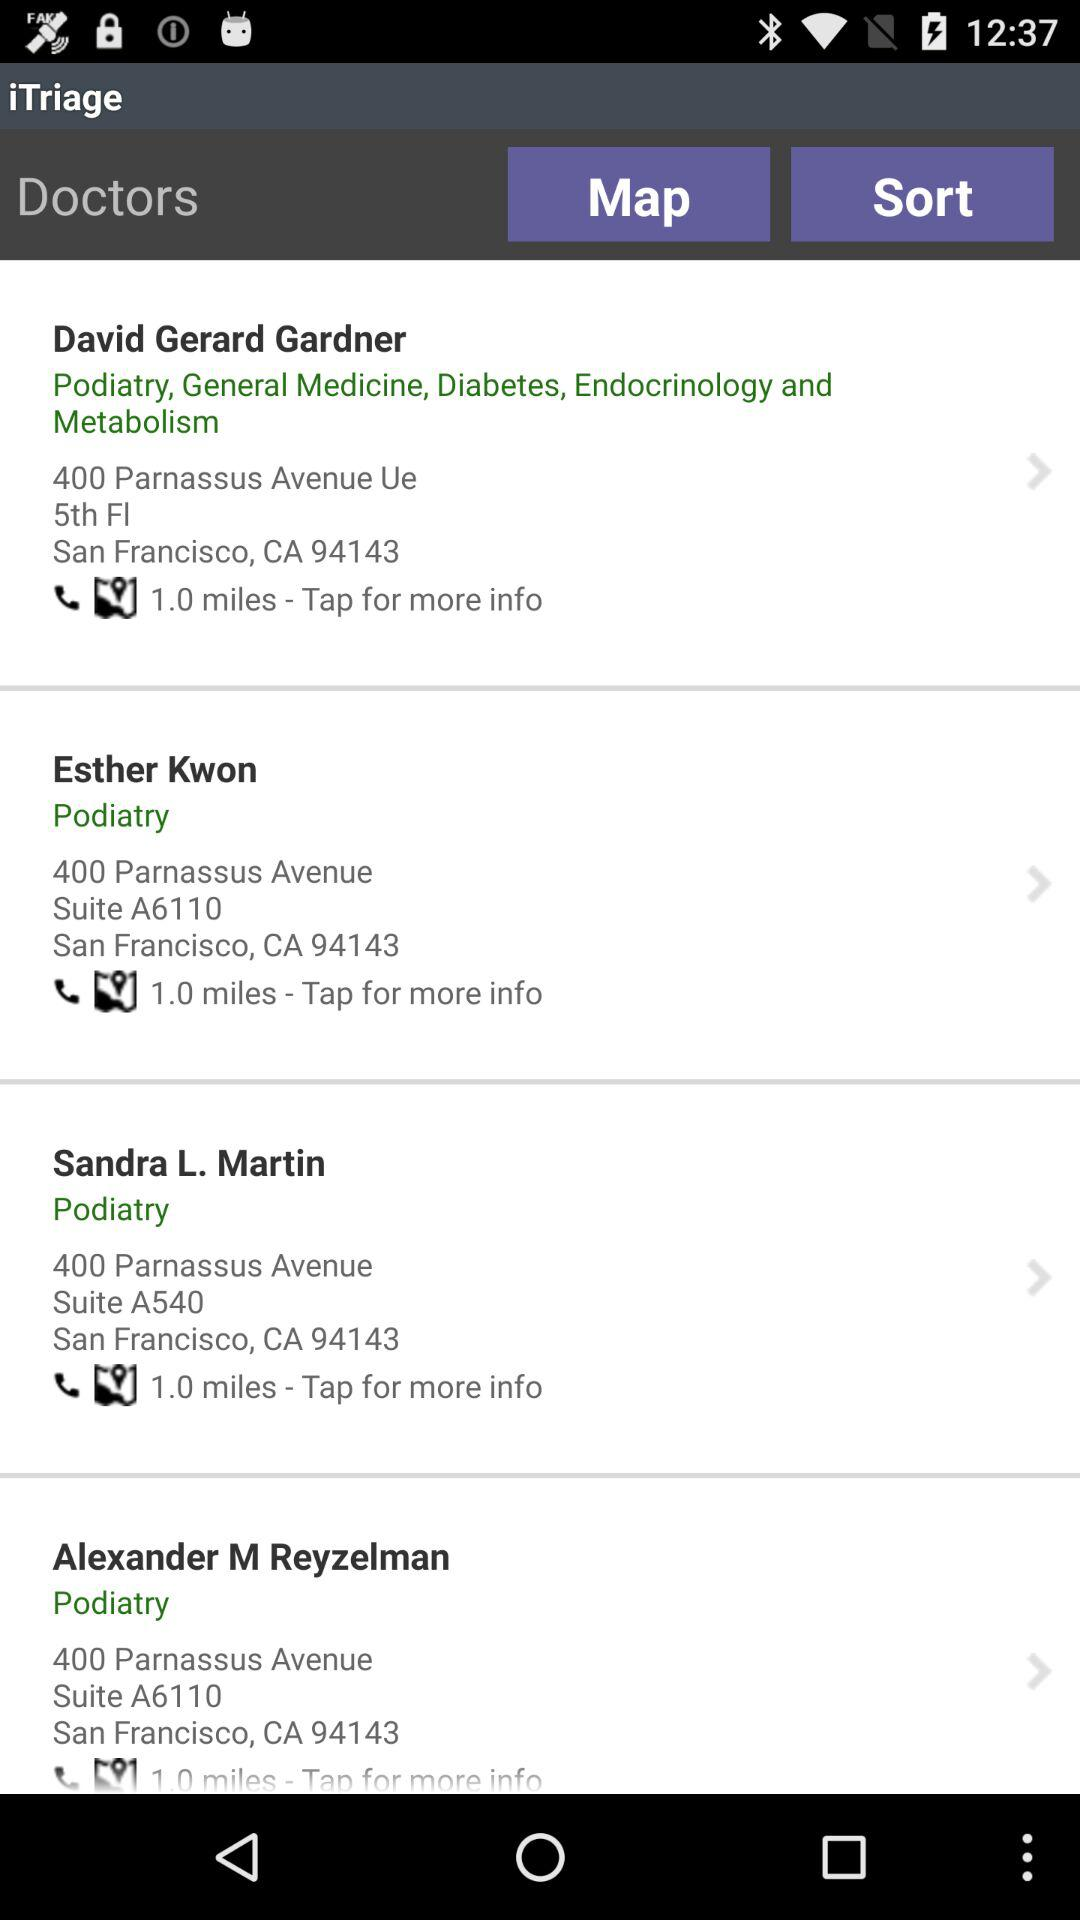What is the address of David Gerard Gardner? The address of David Gerard Gardner is 400 Parnassus Avenue, Ue 5th Fl, San Francisco, CA 94143. 